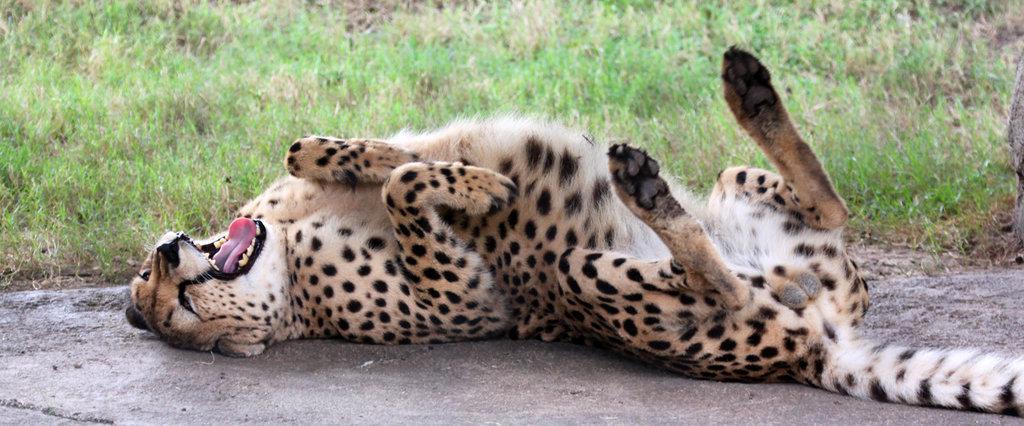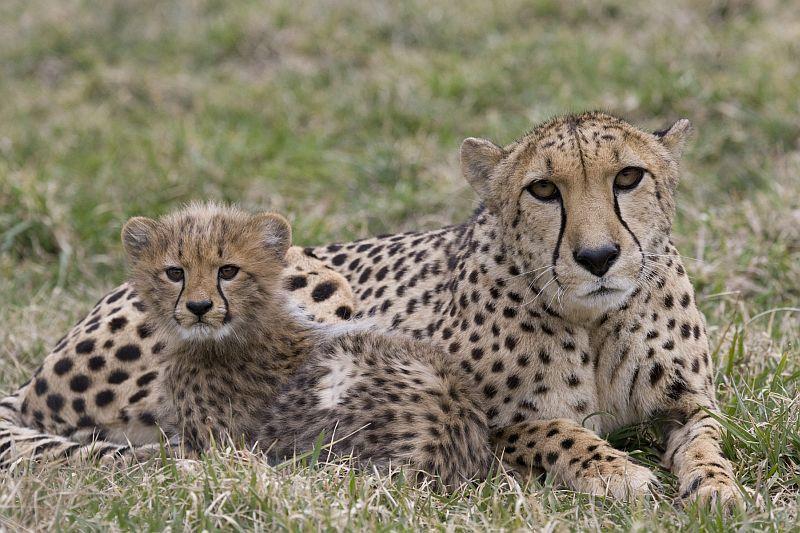The first image is the image on the left, the second image is the image on the right. For the images shown, is this caption "Three cats are lying down, with more in the image on the right." true? Answer yes or no. Yes. The first image is the image on the left, the second image is the image on the right. Assess this claim about the two images: "The left image contains one cheetah, an adult lying on the ground, and the other image features a reclining adult cheetah with its head facing forward on the right, and a cheetah kitten in front of it with its head turned forward on the left.". Correct or not? Answer yes or no. Yes. 